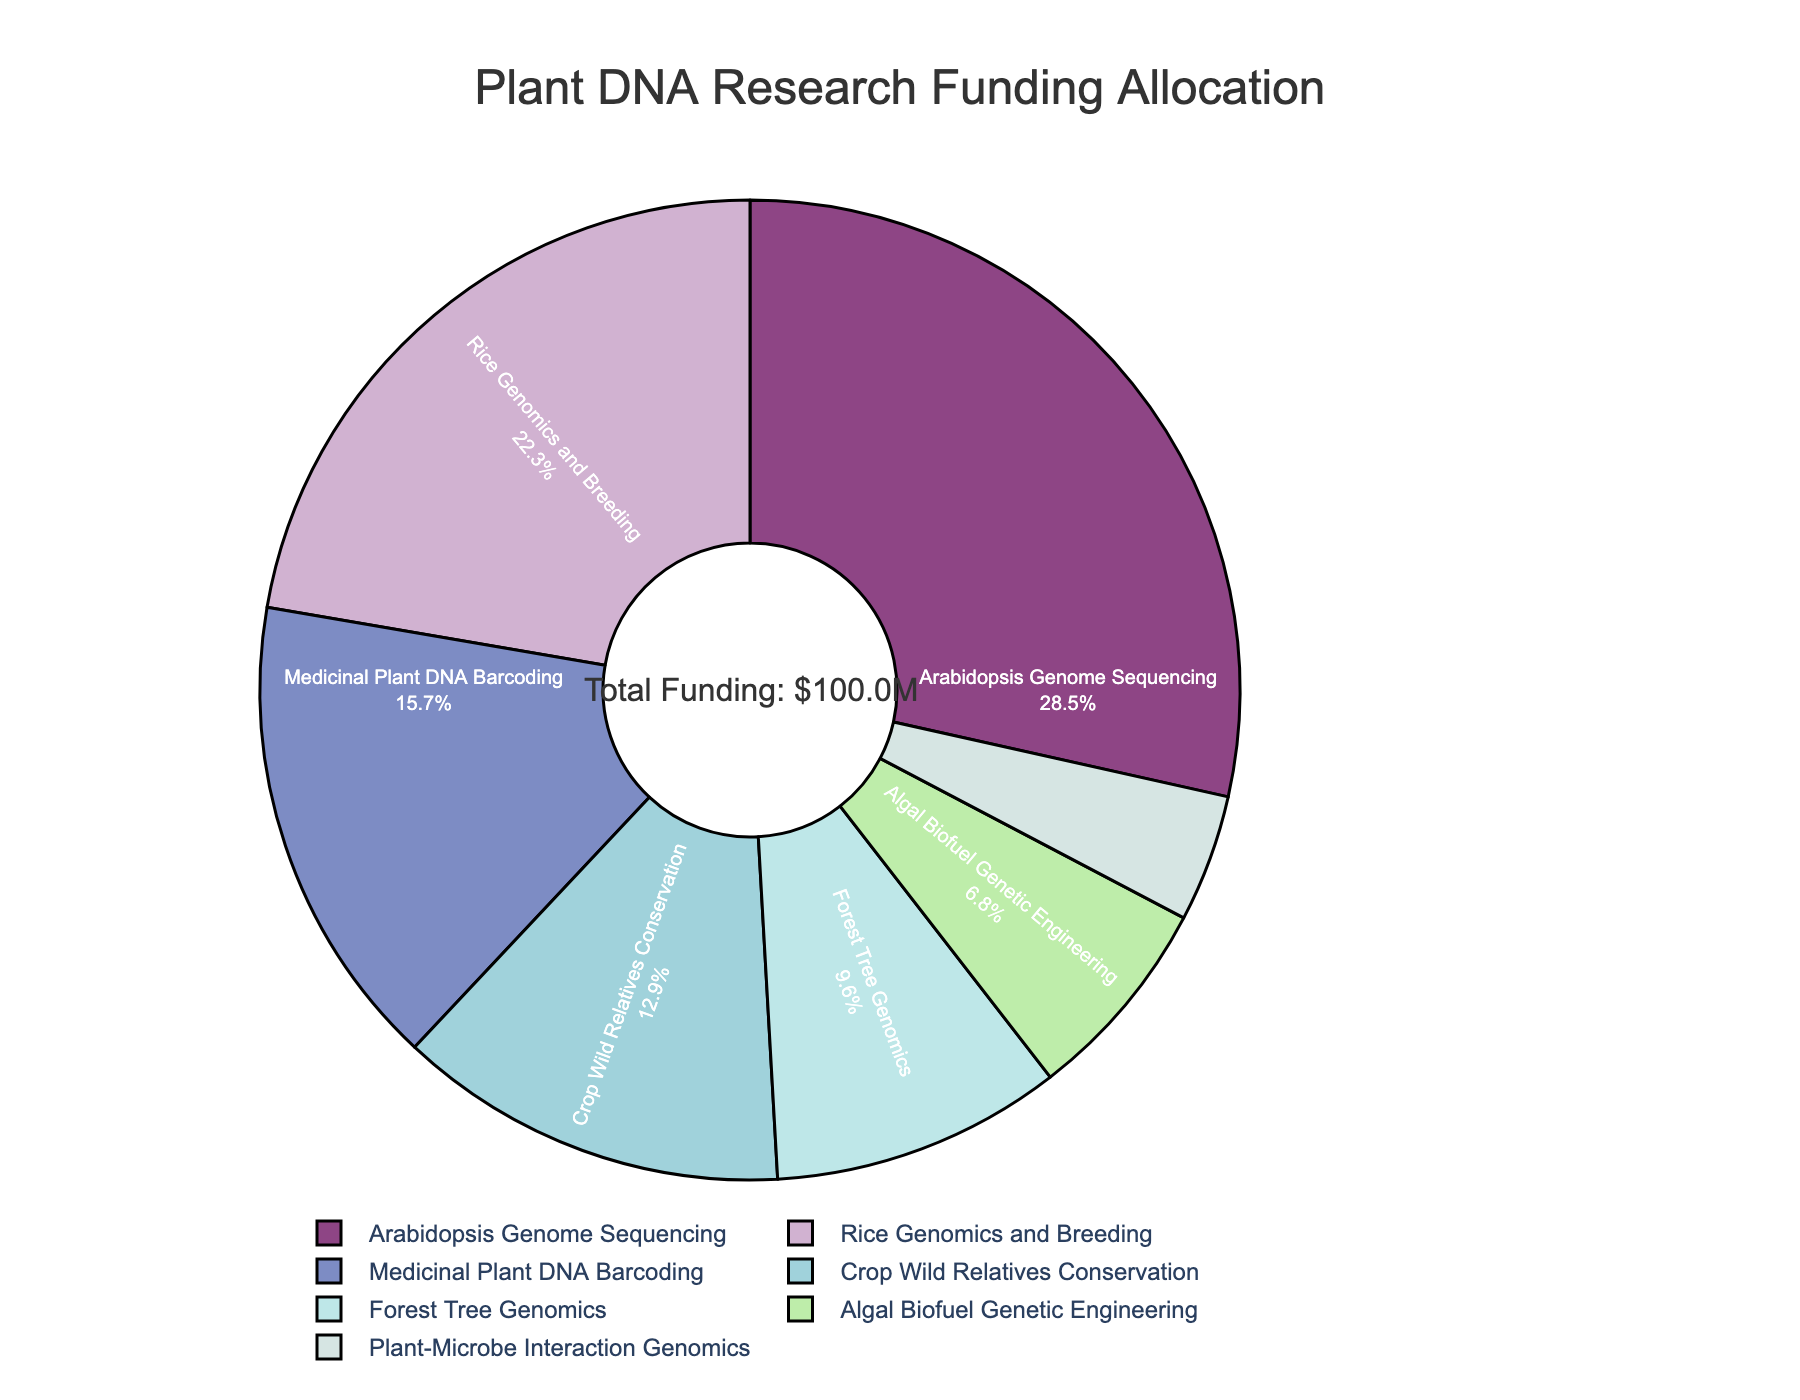What is the largest funding allocation for a single project? Look at the slices of the pie chart to determine the largest portion. The Arabidopsis Genome Sequencing project has the largest slice.
Answer: Arabidopsis Genome Sequencing, 28.5% What is the smallest funding allocation for a single project? Look at the smallest slice of the pie chart. The Plant-Microbe Interaction Genomics project has the smallest slice.
Answer: Plant-Microbe Interaction Genomics, 4.2% What is the combined funding allocation for the Rice Genomics and Breeding and Medicinal Plant DNA Barcoding projects? Add the percentages for Rice Genomics and Breeding (22.3%) and Medicinal Plant DNA Barcoding (15.7%).
Answer: 38.0% Which project has a higher funding allocation, Forest Tree Genomics or Algal Biofuel Genetic Engineering? Compare the slices for Forest Tree Genomics (9.6%) and Algal Biofuel Genetic Engineering (6.8%).
Answer: Forest Tree Genomics What two projects together represent approximately 35% of the funding allocation? Adding the percentages, Arabidopsis Genome Sequencing (28.5%) and Plant-Microbe Interaction Genomics (4.2%) sum to 32.7%; while Rice Genomics and Breeding (22.3%) and Medicinal Plant DNA Barcoding (15.7%) sum to 38%. The closest to 35% is Arabidopsis Genome Sequencing and Crop Wild Relatives Conservation, which is 28.5 + 12.9 = 41.4%.
Answer: No exact match What percentage of the total funding is allocated to Forest Tree Genomics and Algal Biofuel Genetic Engineering combined? Add the percentages for Forest Tree Genomics (9.6%) and Algal Biofuel Genetic Engineering (6.8%).
Answer: 16.4% Which portion is larger, the combined allocation for Forest Tree Genomics and Plant-Microbe Interaction Genomics or the allocation for Arabidopsis Genome Sequencing? Add the percentages for Forest Tree Genomics (9.6%) and Plant-Microbe Interaction Genomics (4.2%). Compare this to Arabidopsis Genome Sequencing (28.5%).
Answer: Arabidopsis Genome Sequencing 